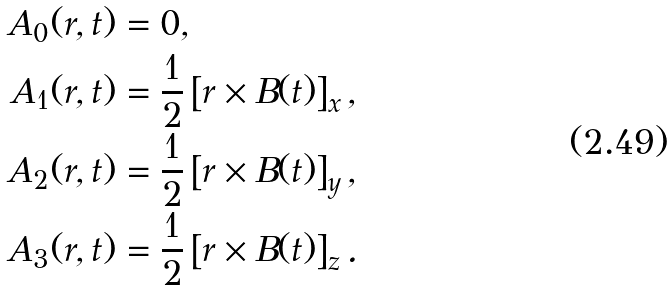Convert formula to latex. <formula><loc_0><loc_0><loc_500><loc_500>A _ { 0 } ( r , t ) & = 0 , \\ A _ { 1 } ( r , t ) & = \frac { 1 } { 2 } \left [ r \times B ( t ) \right ] _ { x } , \\ A _ { 2 } ( r , t ) & = \frac { 1 } { 2 } \left [ r \times B ( t ) \right ] _ { y } , \\ A _ { 3 } ( r , t ) & = \frac { 1 } { 2 } \left [ r \times B ( t ) \right ] _ { z } .</formula> 